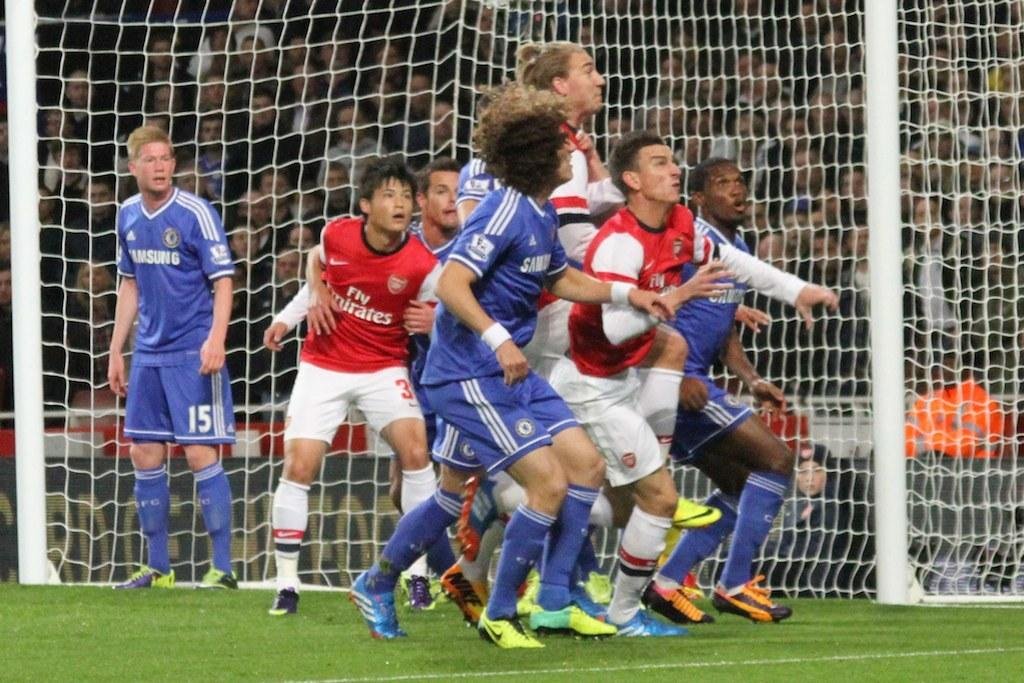<image>
Relay a brief, clear account of the picture shown. Players in red Fly Emirates jerseys push and shove with the blue players on a soccer field. 